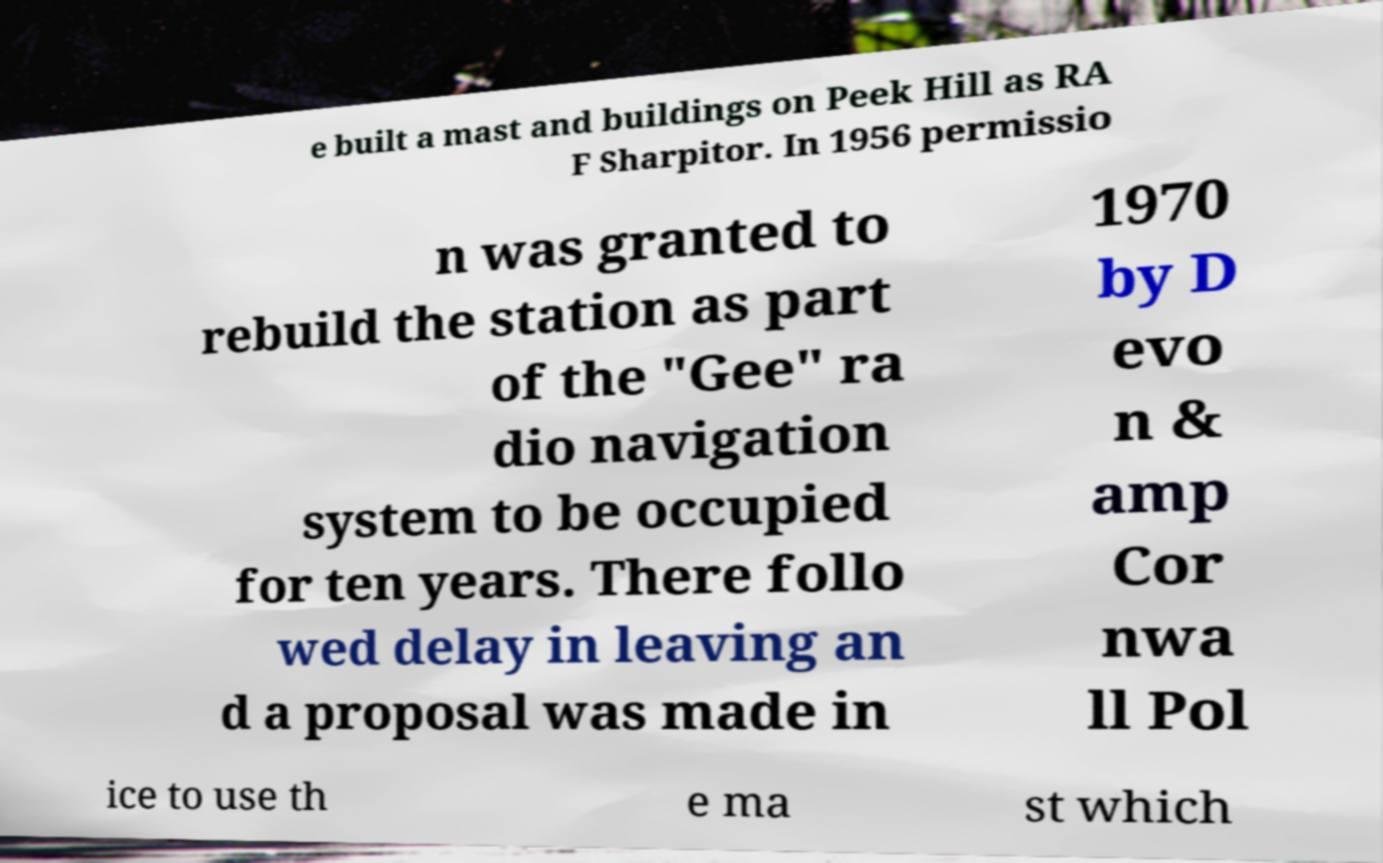Please identify and transcribe the text found in this image. e built a mast and buildings on Peek Hill as RA F Sharpitor. In 1956 permissio n was granted to rebuild the station as part of the "Gee" ra dio navigation system to be occupied for ten years. There follo wed delay in leaving an d a proposal was made in 1970 by D evo n & amp Cor nwa ll Pol ice to use th e ma st which 